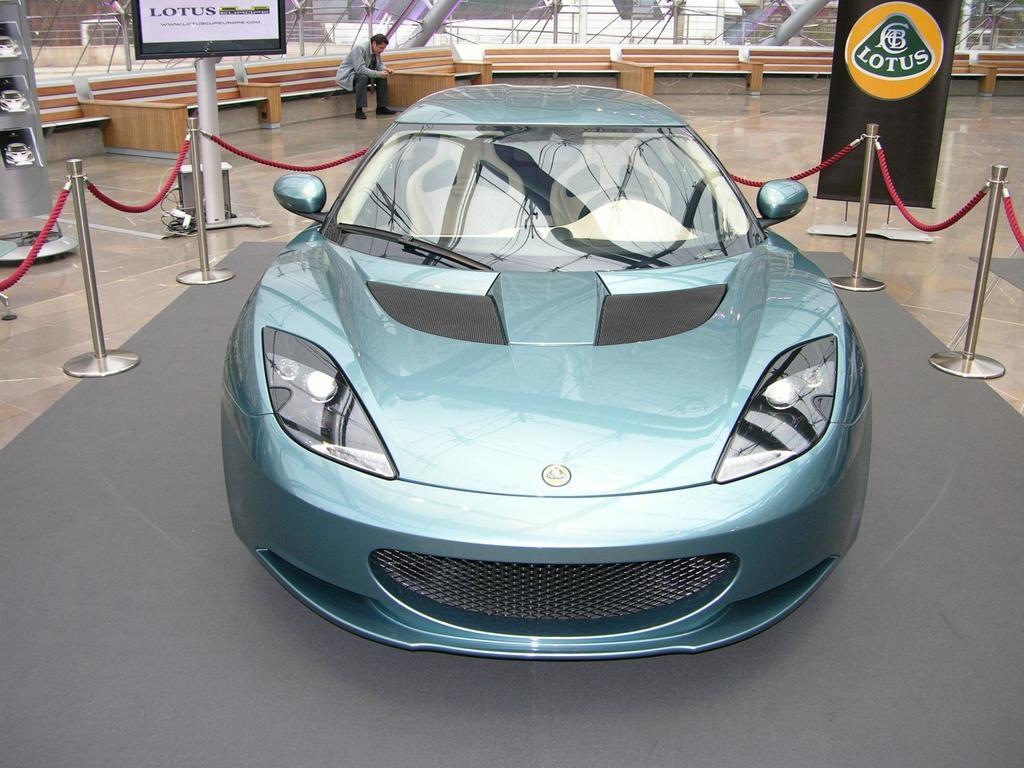What is the main subject of the image? There is a car in the image. Where is the car located? The car is on the floor. What can be seen in the background of the image? There is a fence, banners, and a person visible in the background of the image. Are there any other objects visible in the background? Yes, there are other objects visible in the background of the image. What type of advice can be seen written on the car in the image? There is no advice visible on the car in the image. How many pizzas are being delivered by the person in the background of the image? There is no person delivering pizzas in the image; the person is simply visible in the background. 